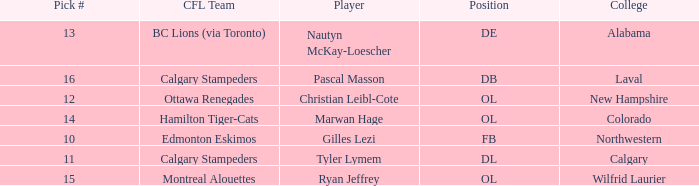Which player from the 2004 CFL draft attended Wilfrid Laurier? Ryan Jeffrey. 